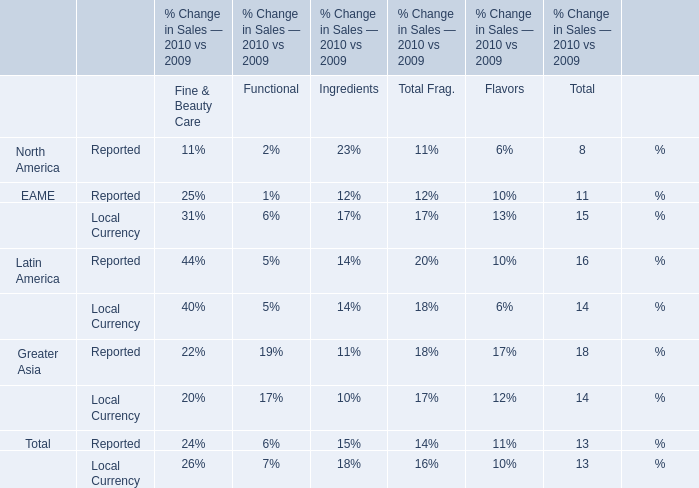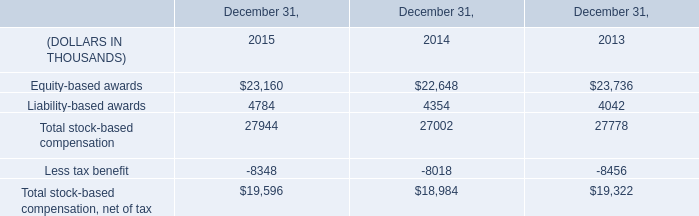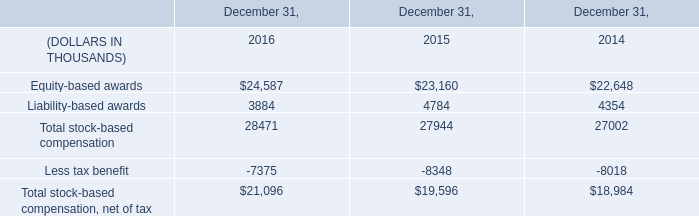When is Total Sales Reported for Flavors larger between 2009 and 2010? 
Answer: 2010. 